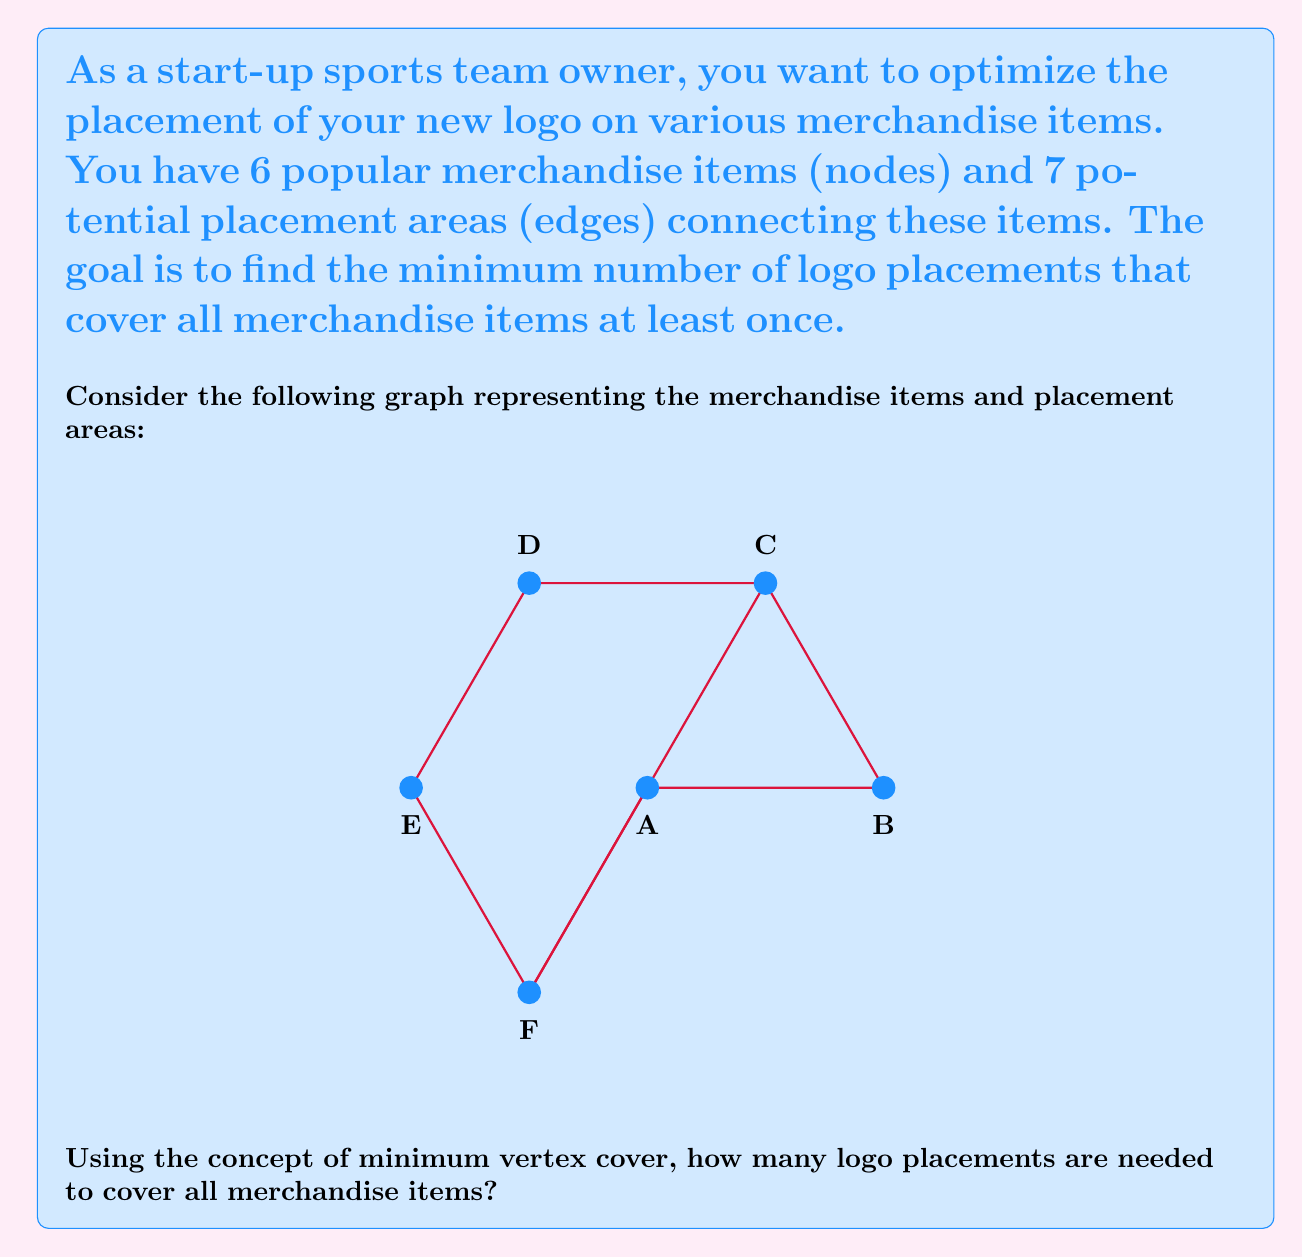Help me with this question. To solve this problem, we need to find the minimum vertex cover of the given graph. A vertex cover is a set of vertices such that each edge of the graph is incident to at least one vertex of the set. The minimum vertex cover is the smallest such set.

Let's approach this step-by-step:

1) First, observe that the graph is a cycle of 6 nodes with one additional edge (C-F).

2) For a cycle with an even number of nodes, the minimum vertex cover is exactly half of the nodes. This is because we can select every other node in the cycle to cover all edges.

3) In our case, we have 6 nodes in the cycle, so we would need 3 nodes to cover the cycle.

4) However, we have an additional edge (C-F) that needs to be considered. This edge is already covered if we choose either C or F in our vertex cover.

5) Therefore, we can select a minimum vertex cover as follows:
   - Choose B, D, and F
   or
   - Choose A, C, and E

6) Either of these selections will cover all edges of the graph, including the additional C-F edge.

7) Thus, the minimum vertex cover for this graph contains 3 vertices.

In the context of logo placement, this means we need to place the logo on 3 different merchandise items to ensure that all potential placement areas (edges) are covered at least once.
Answer: 3 logo placements 